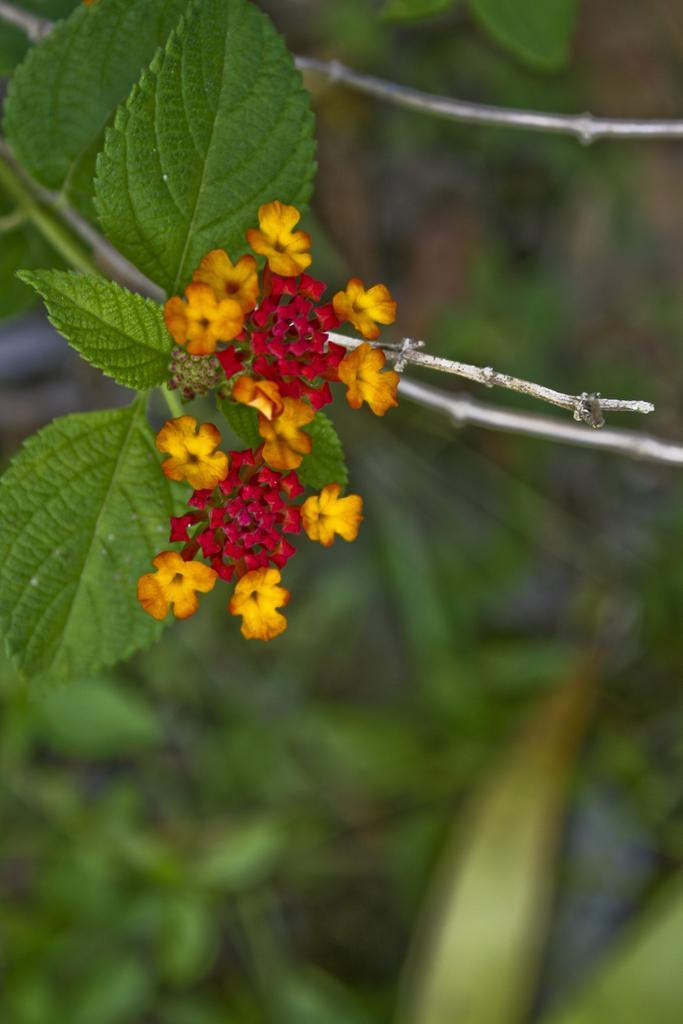How would you summarize this image in a sentence or two? In this image I can see few flowers which are red, yellow and orange in color to a plant which is green in color. I can see the blurry background in which I can see few plants. 